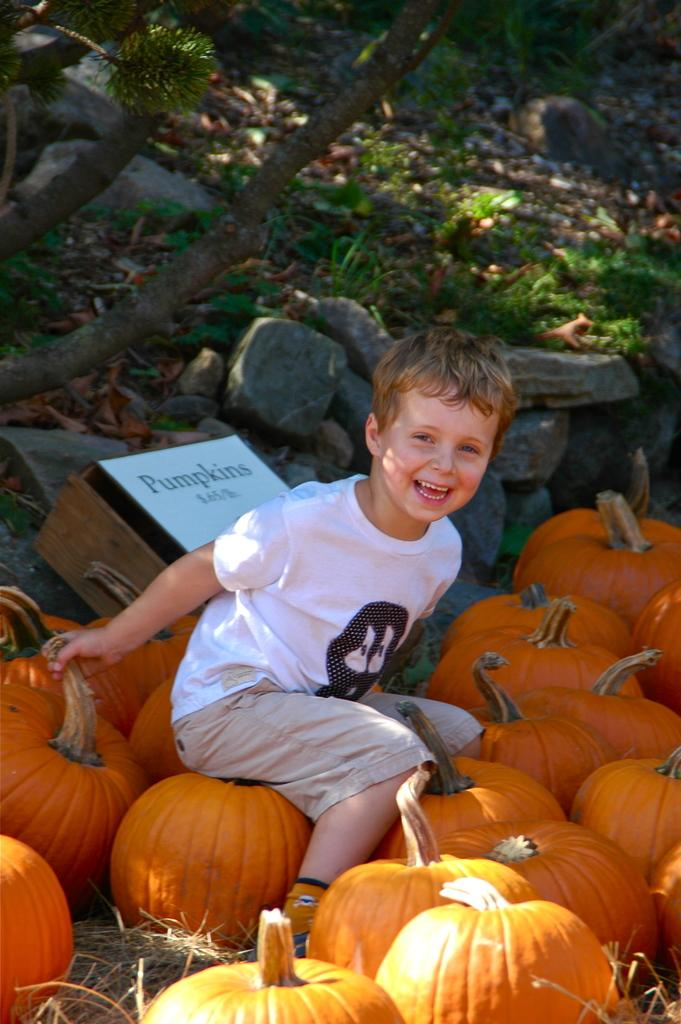Who is the main subject in the image? There is a boy in the image. What is the boy doing in the image? The boy is sitting on pumpkins. What is the boy's facial expression in the image? The boy is smiling. What other objects can be seen in the image? There is a box, stones, and grass in the image. What type of wool is being used to create the clouds in the image? There are no clouds or wool present in the image. 